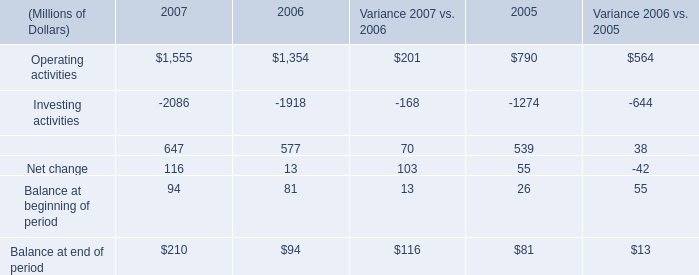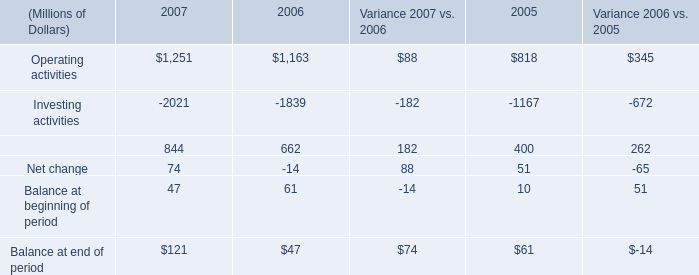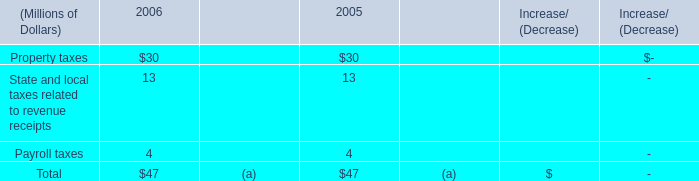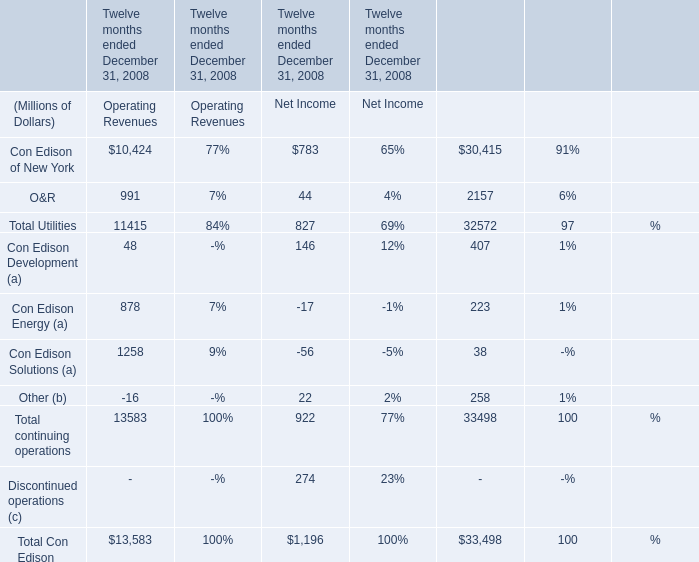What's the total value of all elements that are smaller than 200 in Net Income?? (in Million) 
Computations: ((((44 - 17) - 56) + 22) + 146)
Answer: 139.0. 